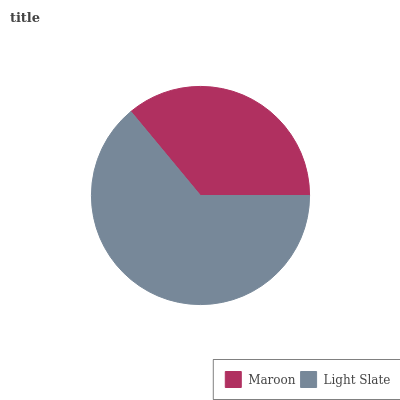Is Maroon the minimum?
Answer yes or no. Yes. Is Light Slate the maximum?
Answer yes or no. Yes. Is Light Slate the minimum?
Answer yes or no. No. Is Light Slate greater than Maroon?
Answer yes or no. Yes. Is Maroon less than Light Slate?
Answer yes or no. Yes. Is Maroon greater than Light Slate?
Answer yes or no. No. Is Light Slate less than Maroon?
Answer yes or no. No. Is Light Slate the high median?
Answer yes or no. Yes. Is Maroon the low median?
Answer yes or no. Yes. Is Maroon the high median?
Answer yes or no. No. Is Light Slate the low median?
Answer yes or no. No. 